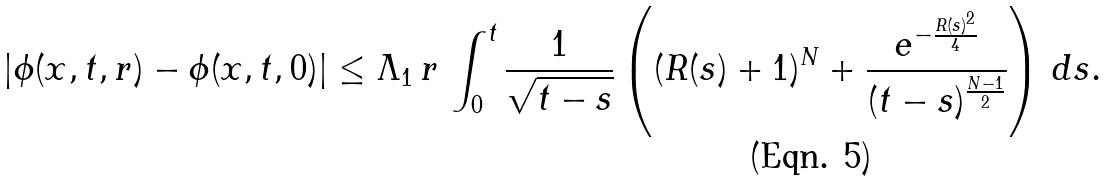<formula> <loc_0><loc_0><loc_500><loc_500>| \phi ( x , t , r ) - \phi ( x , t , 0 ) | \leq \Lambda _ { 1 } \, r \, \int _ { 0 } ^ { t } \frac { 1 } { \sqrt { t - s } } \left ( ( R ( s ) + 1 ) ^ { N } + \frac { e ^ { - \frac { R ( s ) ^ { 2 } } { 4 } } } { ( t - s ) ^ { \frac { N - 1 } { 2 } } } \right ) \, d s .</formula> 